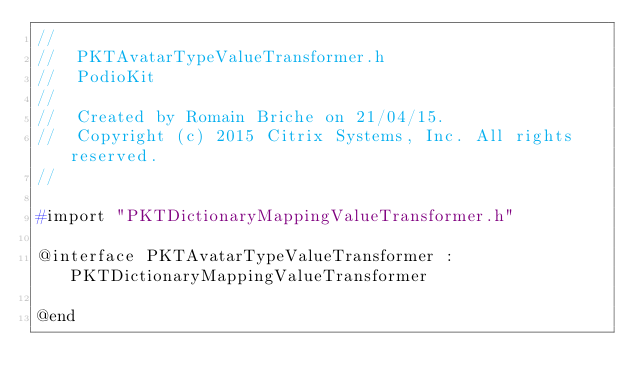Convert code to text. <code><loc_0><loc_0><loc_500><loc_500><_C_>//
//  PKTAvatarTypeValueTransformer.h
//  PodioKit
//
//  Created by Romain Briche on 21/04/15.
//  Copyright (c) 2015 Citrix Systems, Inc. All rights reserved.
//

#import "PKTDictionaryMappingValueTransformer.h"

@interface PKTAvatarTypeValueTransformer : PKTDictionaryMappingValueTransformer

@end
</code> 